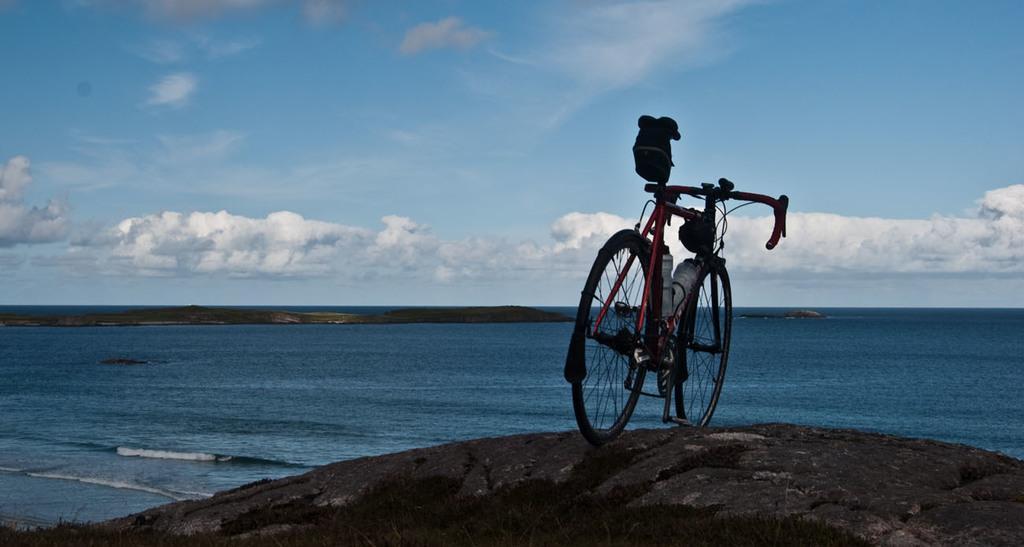Can you describe this image briefly? In the picture we can see a bicycle on the rock surface near the sea and the water is blue in color with some rock surface of the water and we can also see a sky with clouds. 